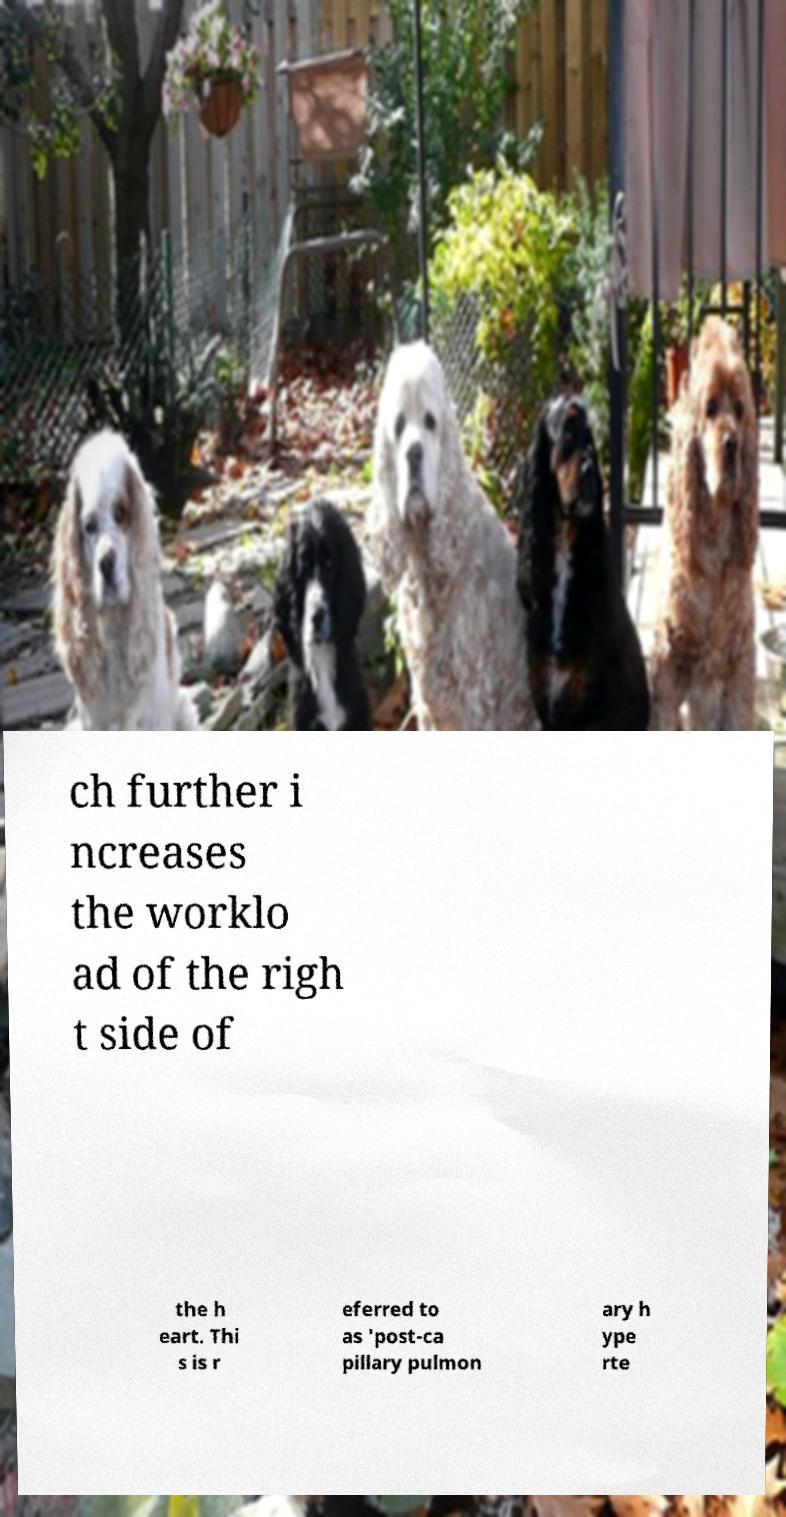Please identify and transcribe the text found in this image. ch further i ncreases the worklo ad of the righ t side of the h eart. Thi s is r eferred to as 'post-ca pillary pulmon ary h ype rte 